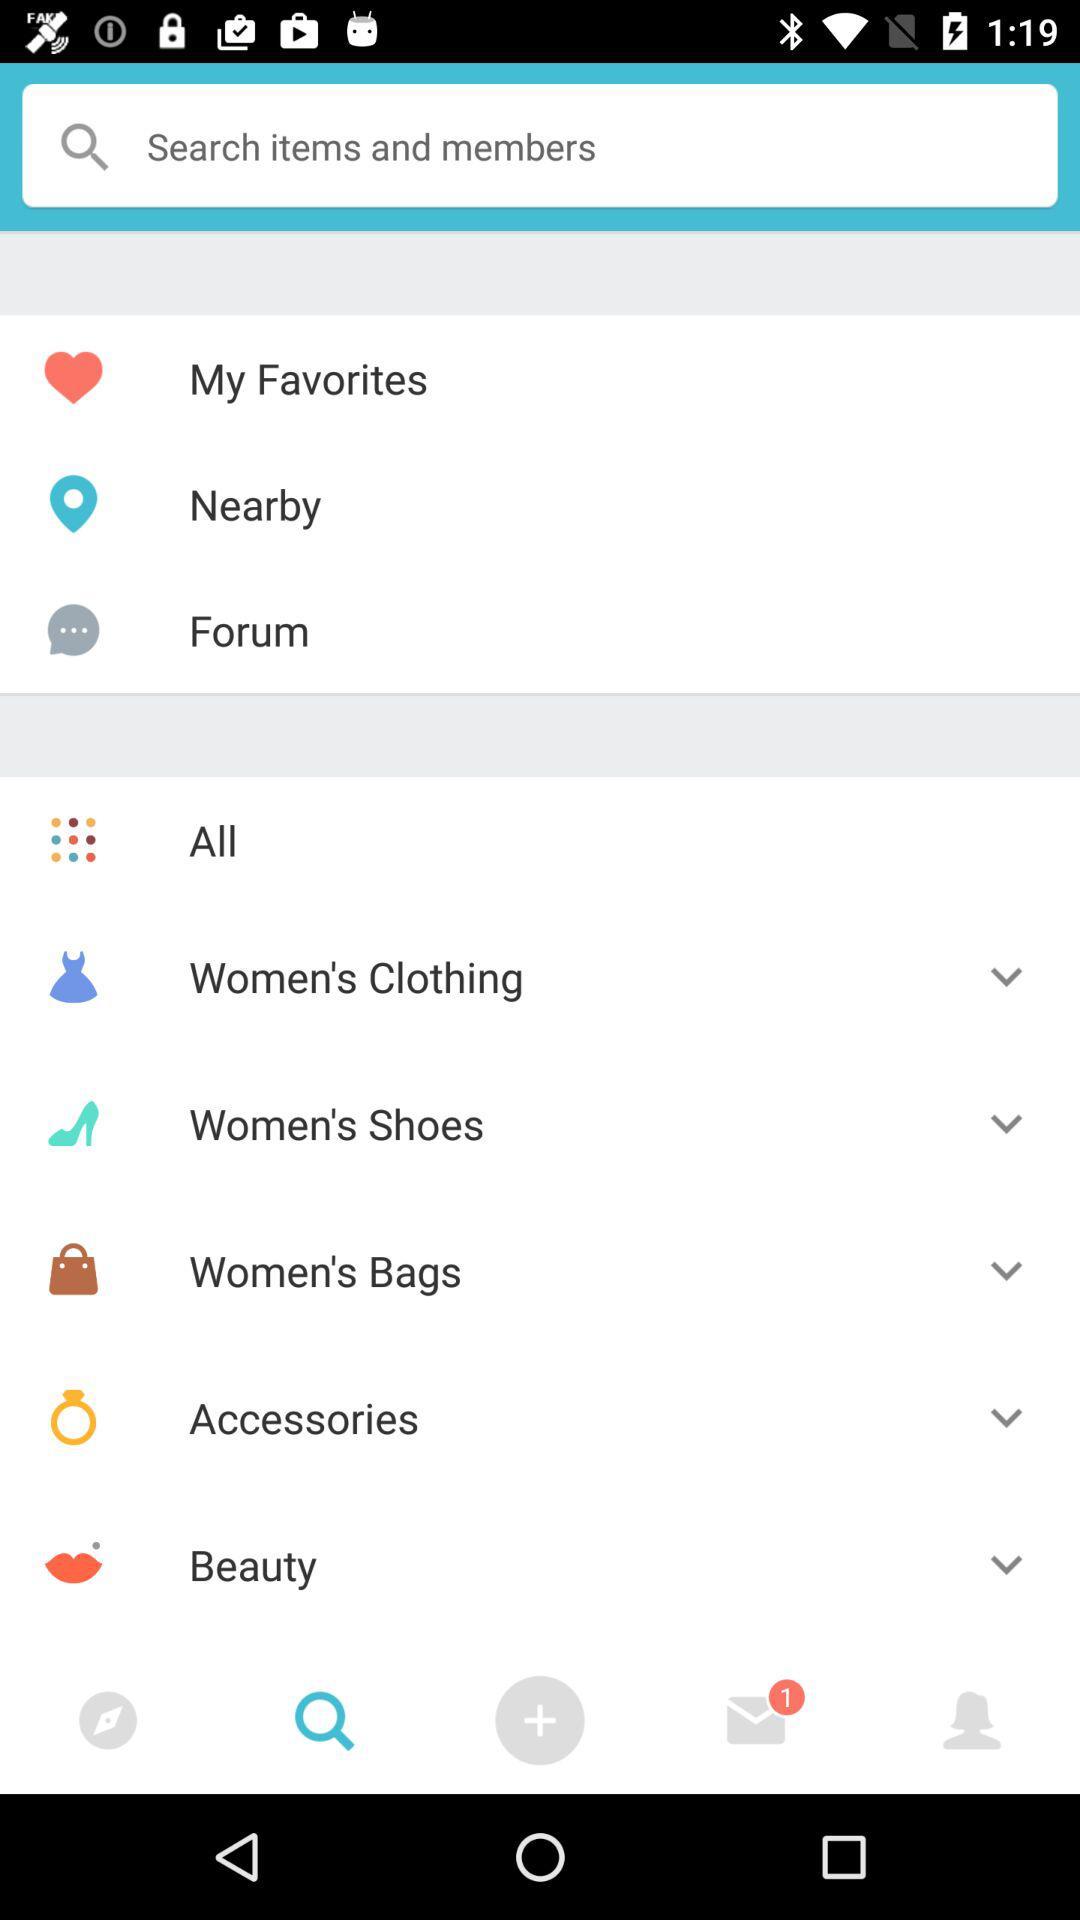How many emails are unread? There is one unread email. 